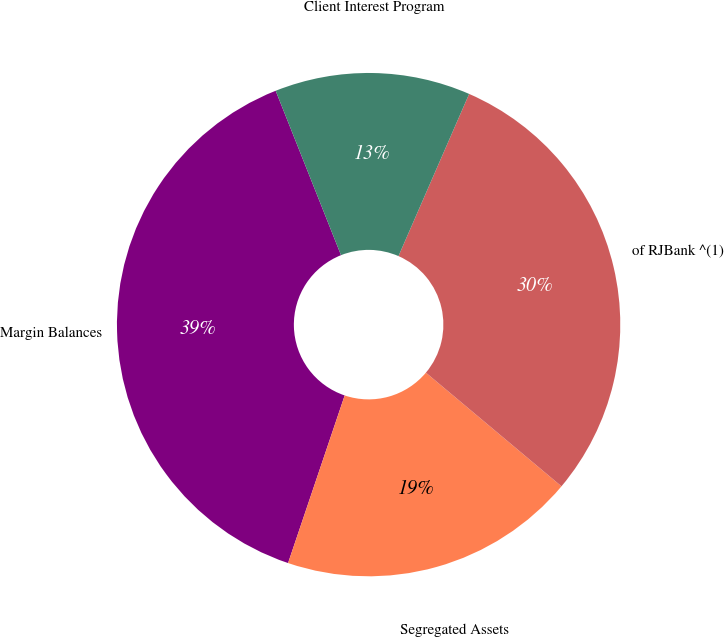Convert chart. <chart><loc_0><loc_0><loc_500><loc_500><pie_chart><fcel>Margin Balances<fcel>Segregated Assets<fcel>of RJBank ^(1)<fcel>Client Interest Program<nl><fcel>38.79%<fcel>19.08%<fcel>29.56%<fcel>12.56%<nl></chart> 